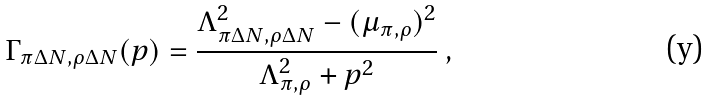<formula> <loc_0><loc_0><loc_500><loc_500>\Gamma _ { \pi \Delta N , \rho \Delta N } ( p ) = \frac { \Lambda _ { \pi \Delta N , \rho \Delta N } ^ { 2 } - ( \mu _ { \pi , \rho } ) ^ { 2 } } { \Lambda _ { \pi , \rho } ^ { 2 } + p ^ { 2 } } \ ,</formula> 